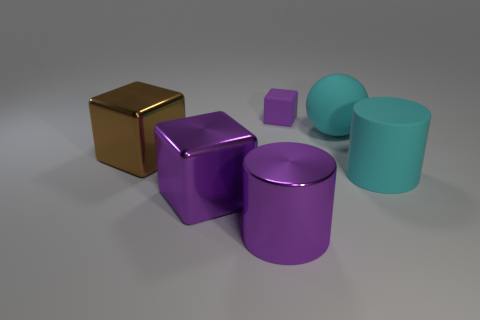What number of large cyan cylinders are there?
Offer a very short reply. 1. There is a purple cube on the left side of the metal cylinder; is it the same size as the rubber object that is in front of the brown metallic block?
Your answer should be very brief. Yes. What color is the tiny matte thing that is the same shape as the large brown thing?
Keep it short and to the point. Purple. Do the tiny thing and the brown object have the same shape?
Your response must be concise. Yes. What size is the other metallic thing that is the same shape as the brown metal object?
Ensure brevity in your answer.  Large. How many other brown things are the same material as the large brown object?
Your response must be concise. 0. How many things are small green metal blocks or large brown metal objects?
Ensure brevity in your answer.  1. There is a big purple shiny object that is behind the big purple metallic cylinder; are there any blocks on the right side of it?
Offer a terse response. Yes. Is the number of large cyan rubber spheres that are in front of the sphere greater than the number of cubes that are right of the big brown metallic block?
Your response must be concise. No. What material is the ball that is the same color as the big matte cylinder?
Your answer should be compact. Rubber. 